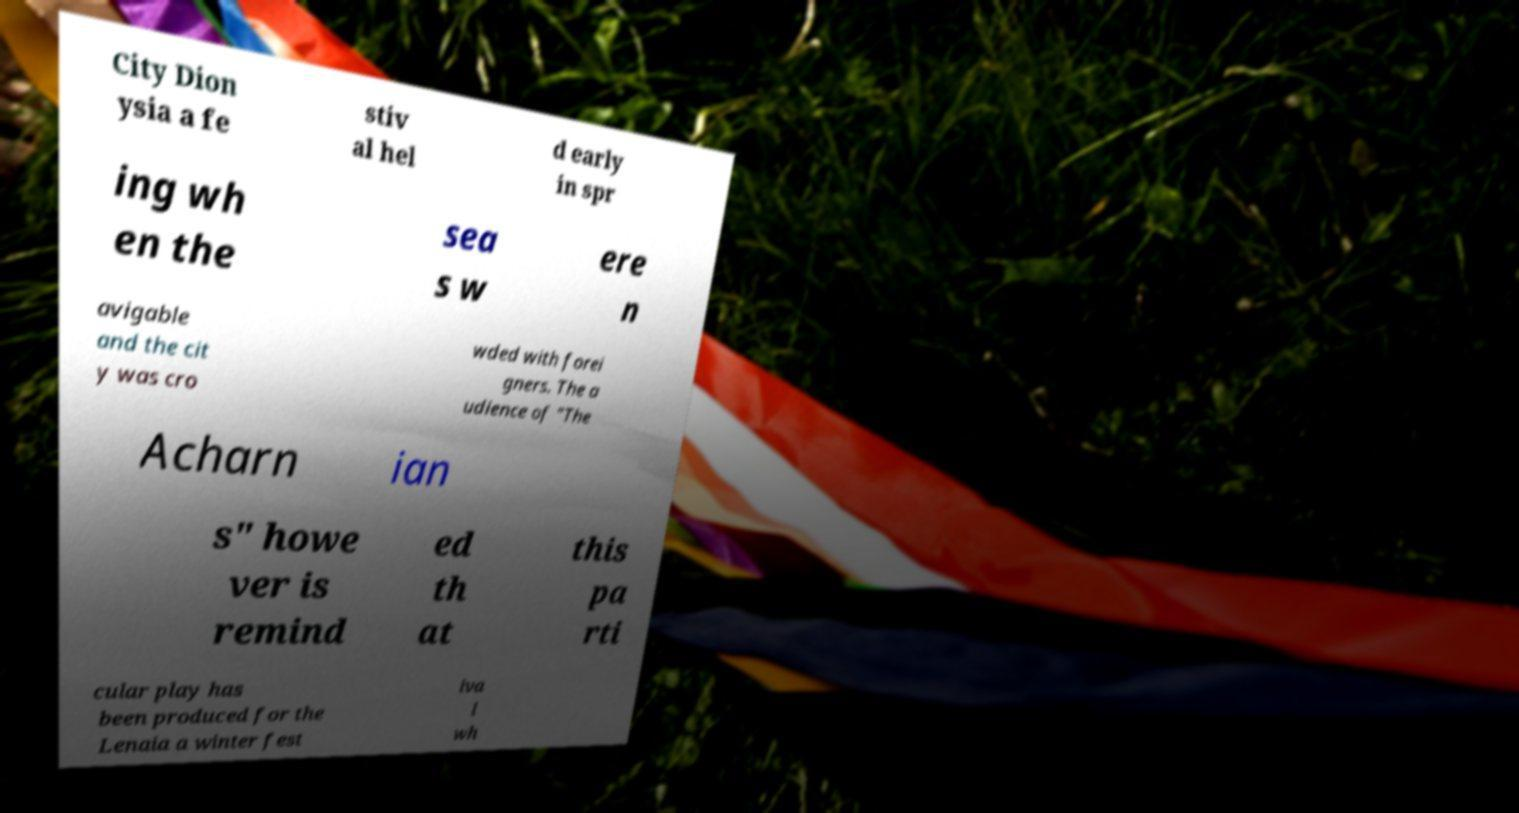Can you accurately transcribe the text from the provided image for me? City Dion ysia a fe stiv al hel d early in spr ing wh en the sea s w ere n avigable and the cit y was cro wded with forei gners. The a udience of "The Acharn ian s" howe ver is remind ed th at this pa rti cular play has been produced for the Lenaia a winter fest iva l wh 